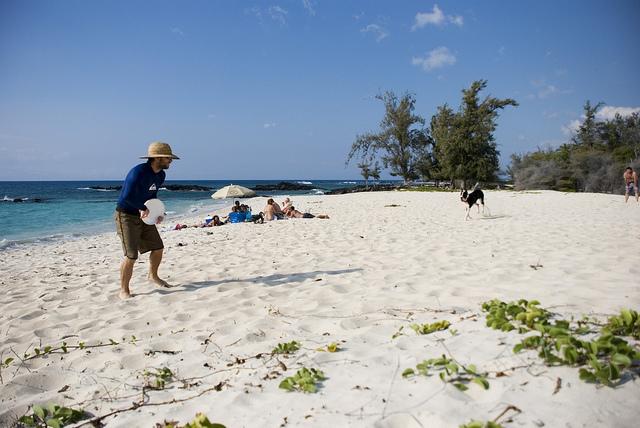What animal is on the beach?
Give a very brief answer. Dog. What color is the frisbee?
Concise answer only. White. What type of animal is this?
Give a very brief answer. Dog. What kind of trees are on the beach?
Write a very short answer. Palm. Is the man trying to catch the frisbee while swimming?
Be succinct. No. How many people are shown?
Concise answer only. 7. What color is the sky?
Answer briefly. Blue. 